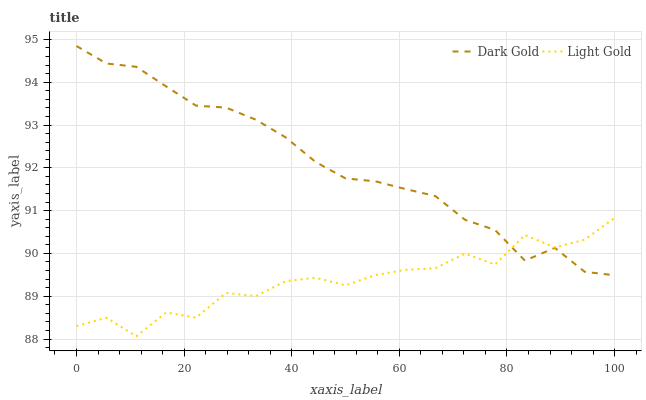Does Light Gold have the minimum area under the curve?
Answer yes or no. Yes. Does Dark Gold have the maximum area under the curve?
Answer yes or no. Yes. Does Dark Gold have the minimum area under the curve?
Answer yes or no. No. Is Dark Gold the smoothest?
Answer yes or no. Yes. Is Light Gold the roughest?
Answer yes or no. Yes. Is Dark Gold the roughest?
Answer yes or no. No. Does Light Gold have the lowest value?
Answer yes or no. Yes. Does Dark Gold have the lowest value?
Answer yes or no. No. Does Dark Gold have the highest value?
Answer yes or no. Yes. Does Dark Gold intersect Light Gold?
Answer yes or no. Yes. Is Dark Gold less than Light Gold?
Answer yes or no. No. Is Dark Gold greater than Light Gold?
Answer yes or no. No. 